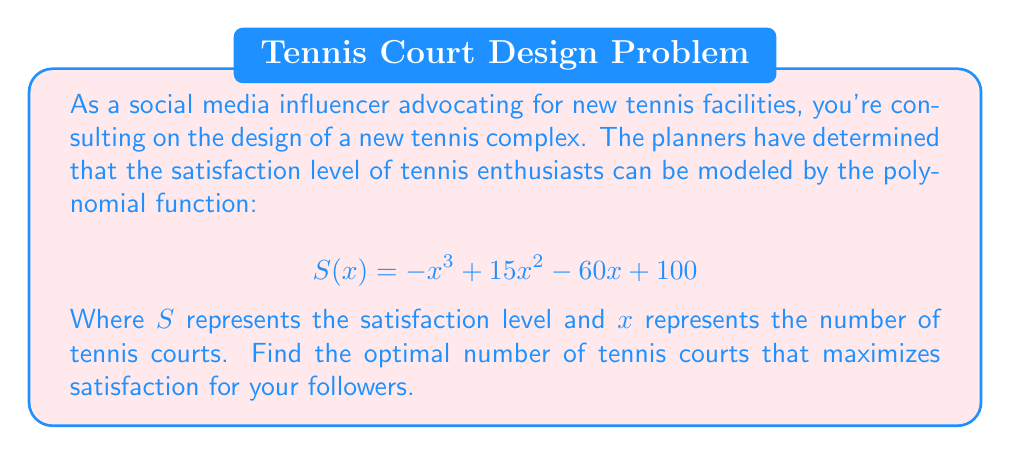Teach me how to tackle this problem. To find the optimal number of tennis courts, we need to find the maximum of the function $S(x)$. This occurs where the derivative of $S(x)$ is zero.

1. First, let's find the derivative of $S(x)$:
   $$ S'(x) = -3x^2 + 30x - 60 $$

2. Set the derivative equal to zero:
   $$ -3x^2 + 30x - 60 = 0 $$

3. This is a quadratic equation. We can solve it using the quadratic formula:
   $$ x = \frac{-b \pm \sqrt{b^2 - 4ac}}{2a} $$
   Where $a = -3$, $b = 30$, and $c = -60$

4. Substituting these values:
   $$ x = \frac{-30 \pm \sqrt{30^2 - 4(-3)(-60)}}{2(-3)} $$
   $$ x = \frac{-30 \pm \sqrt{900 - 720}}{-6} $$
   $$ x = \frac{-30 \pm \sqrt{180}}{-6} $$
   $$ x = \frac{-30 \pm 6\sqrt{5}}{-6} $$

5. Simplifying:
   $$ x = 5 \pm \sqrt{5} $$

6. This gives us two critical points: $5 + \sqrt{5}$ and $5 - \sqrt{5}$

7. To determine which one is the maximum, we can check the second derivative:
   $$ S''(x) = -6x + 30 $$
   
   If $S''(x) < 0$ at a critical point, it's a maximum.

8. Evaluating at $x = 5 + \sqrt{5}$:
   $$ S''(5 + \sqrt{5}) = -6(5 + \sqrt{5}) + 30 = -30 - 6\sqrt{5} + 30 = -6\sqrt{5} < 0 $$

Therefore, the maximum occurs at $x = 5 + \sqrt{5}$.

9. Since we need a whole number of tennis courts, we round to the nearest integer:
   $$ 5 + \sqrt{5} \approx 7.24 $$
   Rounding to the nearest integer gives us 7.
Answer: The optimal number of tennis courts is 7. 